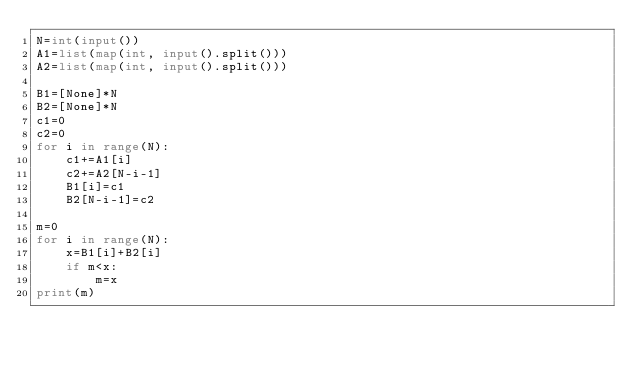<code> <loc_0><loc_0><loc_500><loc_500><_Python_>N=int(input())
A1=list(map(int, input().split()))
A2=list(map(int, input().split()))

B1=[None]*N
B2=[None]*N
c1=0
c2=0
for i in range(N):
    c1+=A1[i]
    c2+=A2[N-i-1]
    B1[i]=c1
    B2[N-i-1]=c2

m=0
for i in range(N):
    x=B1[i]+B2[i]
    if m<x:
        m=x
print(m)
</code> 